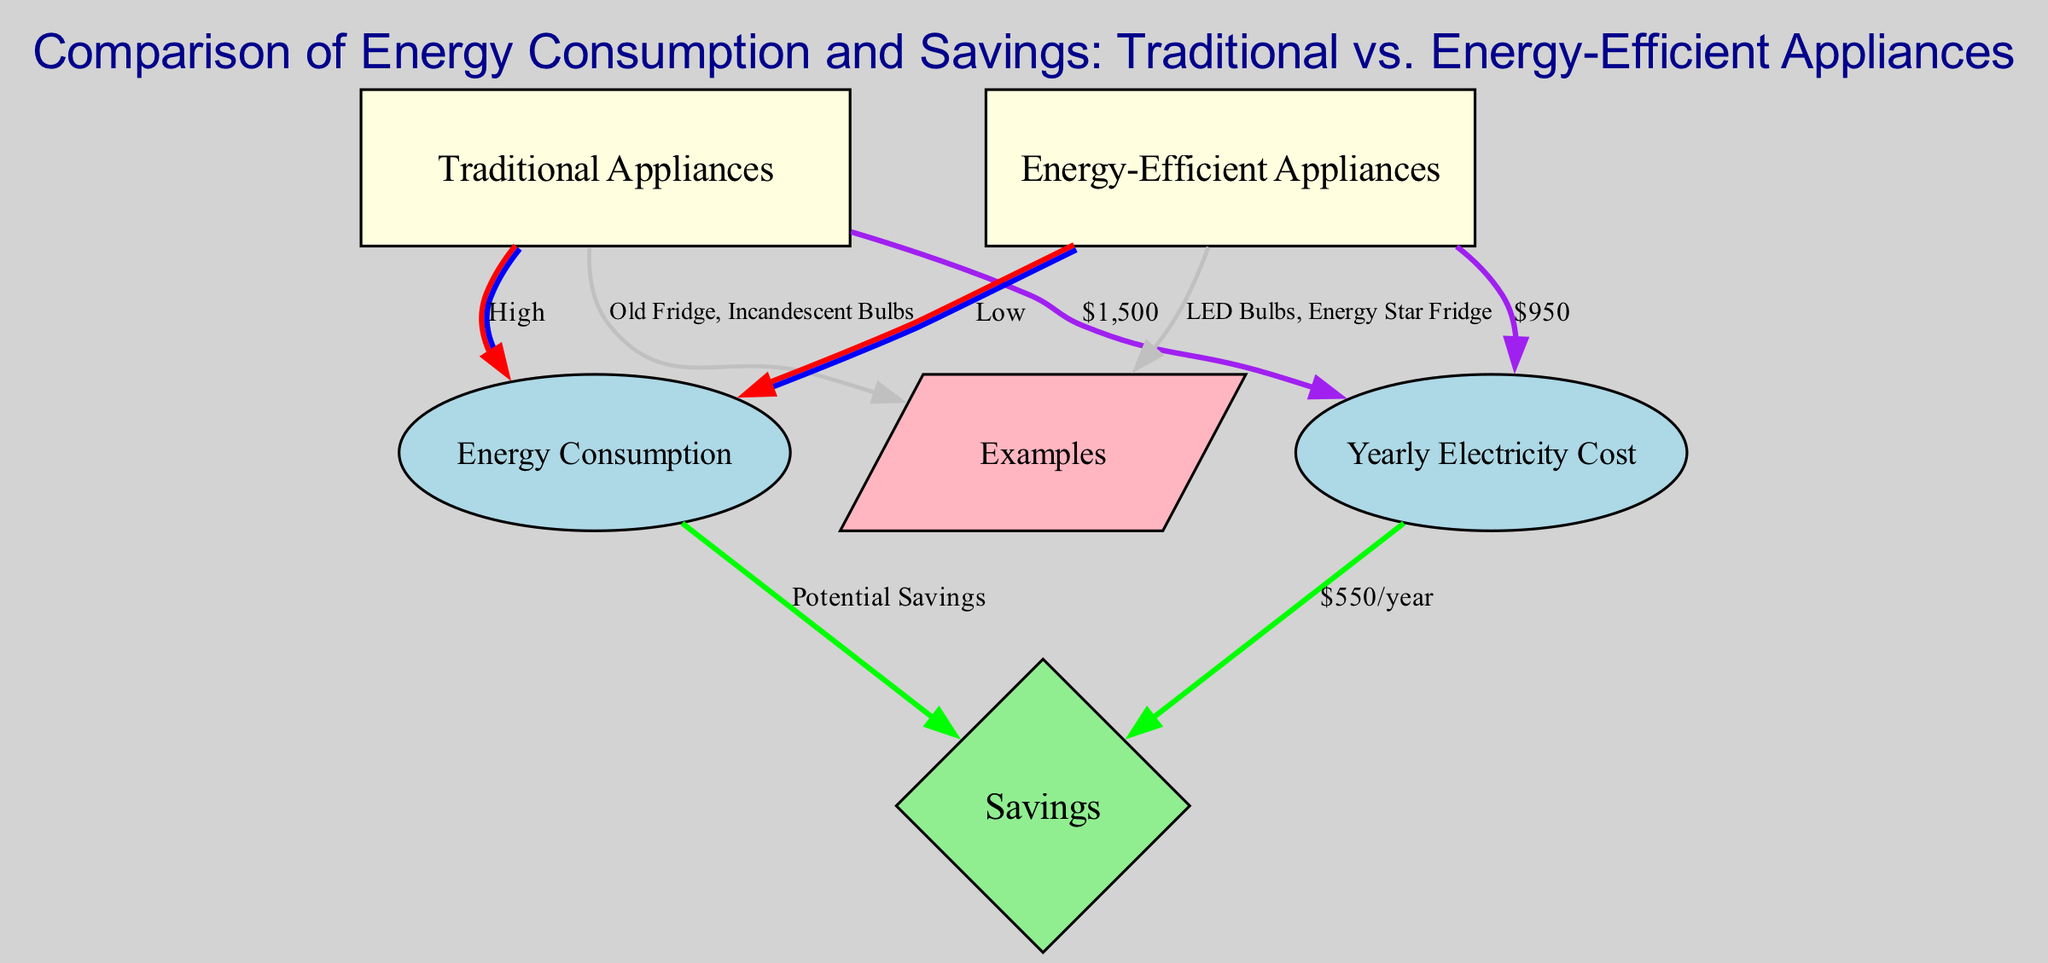What is the yearly electricity cost for traditional appliances? The diagram states that the yearly electricity cost for traditional appliances is $1,500 indicated by the edge connecting "Traditional Appliances" to "Yearly Electricity Cost."
Answer: $1,500 What energy consumption level is associated with energy-efficient appliances? The diagram notes that energy-efficient appliances have a "Low" level of energy consumption, as shown by the edge connecting "Energy-Efficient Appliances" to "Energy Consumption."
Answer: Low How much can be saved per year by using energy-efficient appliances? The diagram indicates that using energy-efficient appliances can lead to potential savings of $550 per year, shown by the edge connecting "Yearly Electricity Cost" to "Savings."
Answer: $550 What examples are given for traditional appliances? The diagram lists "Old Fridge, Incandescent Bulbs" as examples of traditional appliances, as noted by the edge from "Traditional Appliances" to "Examples."
Answer: Old Fridge, Incandescent Bulbs What is the total electricity cost difference between the two types of appliances? The yearly cost for traditional appliances is $1,500 and for energy-efficient appliances is $950. Therefore, subtracting these values gives $1,500 - $950 = $550, which represents the cost difference.
Answer: $550 Which type of appliance has higher energy consumption? The diagram clearly connects "Traditional Appliances" to "Energy Consumption" with a label of "High," indicating that traditional appliances consume more energy than energy-efficient ones.
Answer: Traditional Appliances How are savings defined in relation to energy consumption? The diagram shows that savings are defined as "Potential Savings" linked to "Energy Consumption," implying that higher energy consumption results in lower savings. Thus, energy-efficient appliances lead to greater potential savings by consuming less energy.
Answer: Potential Savings What color represents energy-efficient appliances in the diagram? The diagram uses light yellow as the fill color for the "Energy-Efficient Appliances" node, as specified in the graph node attributes.
Answer: Light yellow 